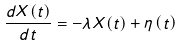Convert formula to latex. <formula><loc_0><loc_0><loc_500><loc_500>\frac { d X ( t ) } { d t } = - \lambda X ( t ) + \eta \left ( t \right )</formula> 